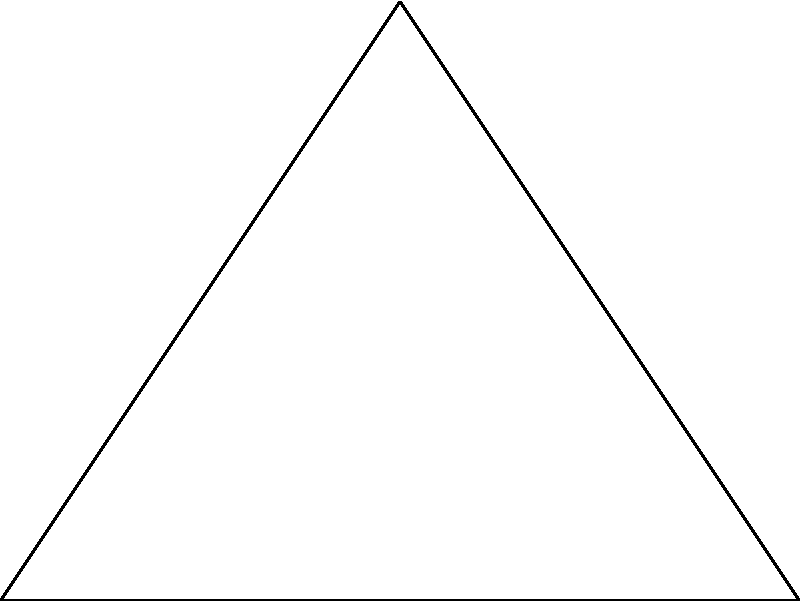In the diagram above, three circular cloud formations are centered at the vertices of triangle ABC. Point P represents a rain droplet. If the radii of all circles are equal to 1 unit, what is the probability that the rain droplet will fall within at least one of the cloud formations? To solve this problem, we'll follow these steps:

1) First, we need to calculate the area of each circle:
   Area of one circle = $\pi r^2 = \pi (1)^2 = \pi$

2) The total area of the three circles if they didn't overlap would be:
   $3\pi$

3) However, the circles do overlap. We need to subtract the areas of overlap to avoid counting them twice.

4) The overlapping areas form lens shapes. The area of a lens can be calculated using the formula:
   $A_{lens} = 2r^2 \arccos(\frac{d}{2r}) - d\sqrt{r^2 - (\frac{d}{2})^2}$
   where $r$ is the radius and $d$ is the distance between the centers.

5) The distance between the centers (side lengths of the triangle) can be calculated using the distance formula:
   $AB = 4$
   $BC = AC = \sqrt{2^2 + 3^2} = \sqrt{13}$

6) Now we can calculate the area of each lens:
   For AB: $A_{lens} = 2(1)^2 \arccos(\frac{4}{2(1)}) - 4\sqrt{1^2 - (\frac{4}{2})^2} = 0$ (no overlap)
   For BC and AC: $A_{lens} = 2(1)^2 \arccos(\frac{\sqrt{13}}{2(1)}) - \sqrt{13}\sqrt{1^2 - (\frac{\sqrt{13}}{2})^2}$

7) The total area covered by the clouds is:
   $A_{total} = 3\pi - 2A_{lens}$

8) The probability is this area divided by the total area of the triangle:
   $P = \frac{A_{total}}{\frac{1}{2}(4)(3)} = \frac{A_{total}}{6}$

This gives us the probability that a rain droplet will fall within at least one cloud formation.
Answer: $\frac{3\pi - 2(2\arccos(\frac{\sqrt{13}}{2}) - \sqrt{13}\sqrt{1 - (\frac{\sqrt{13}}{2})^2})}{6}$ 